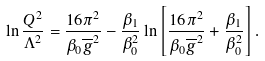Convert formula to latex. <formula><loc_0><loc_0><loc_500><loc_500>\ln \frac { Q ^ { 2 } } { \Lambda ^ { 2 } } = \frac { 1 6 \pi ^ { 2 } } { \beta _ { 0 } \overline { g } ^ { 2 } } - \frac { \beta _ { 1 } } { \beta _ { 0 } ^ { 2 } } \ln \left [ \frac { 1 6 \pi ^ { 2 } } { \beta _ { 0 } \overline { g } ^ { 2 } } + \frac { \beta _ { 1 } } { \beta _ { 0 } ^ { 2 } } \right ] .</formula> 